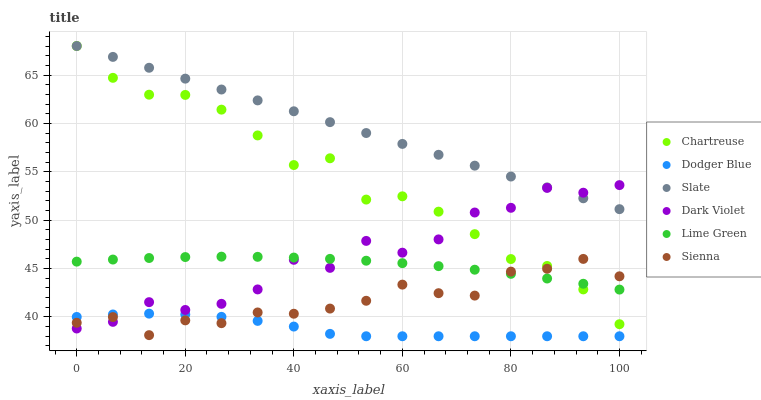Does Dodger Blue have the minimum area under the curve?
Answer yes or no. Yes. Does Slate have the maximum area under the curve?
Answer yes or no. Yes. Does Dark Violet have the minimum area under the curve?
Answer yes or no. No. Does Dark Violet have the maximum area under the curve?
Answer yes or no. No. Is Slate the smoothest?
Answer yes or no. Yes. Is Dark Violet the roughest?
Answer yes or no. Yes. Is Sienna the smoothest?
Answer yes or no. No. Is Sienna the roughest?
Answer yes or no. No. Does Dodger Blue have the lowest value?
Answer yes or no. Yes. Does Dark Violet have the lowest value?
Answer yes or no. No. Does Chartreuse have the highest value?
Answer yes or no. Yes. Does Dark Violet have the highest value?
Answer yes or no. No. Is Dodger Blue less than Chartreuse?
Answer yes or no. Yes. Is Chartreuse greater than Dodger Blue?
Answer yes or no. Yes. Does Slate intersect Chartreuse?
Answer yes or no. Yes. Is Slate less than Chartreuse?
Answer yes or no. No. Is Slate greater than Chartreuse?
Answer yes or no. No. Does Dodger Blue intersect Chartreuse?
Answer yes or no. No. 